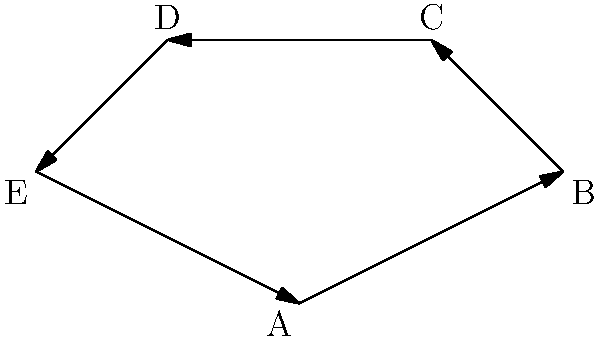In the directed cyclic graph above, each node represents a different point in time, and each edge represents a time travel event. If a time traveler starts at point A and follows the path of the graph, which temporal paradox is most likely to occur, and why is this paradox particularly relevant to classic 1960s sci-fi storytelling? To answer this question, let's break down the analysis step-by-step:

1. Graph structure: The graph is a directed cycle with 5 nodes (A, B, C, D, E) connected in a loop.

2. Time travel interpretation:
   - Each node represents a distinct point in time.
   - Each edge represents a time travel event from one point to another.
   - The cycle suggests that a traveler can eventually return to their starting point in time.

3. Paradox identification: The most likely paradox to occur in this scenario is the "Causal Loop" or "Bootstrap Paradox."

4. Explanation of the Causal Loop:
   - The time traveler starts at A and moves through time to B, C, D, E, and back to A.
   - This creates a closed timelike curve where events influence themselves.
   - Information or objects can exist without a clear point of origin.

5. Relevance to 1960s sci-fi:
   - Classic shows like "The Twilight Zone" and "Star Trek" often explored time travel.
   - These shows frequently used paradoxes to create mind-bending storylines.
   - The Causal Loop allows for complex, interconnected plots that challenge causality.

6. Storytelling potential:
   - It raises questions about free will and determinism.
   - It allows for creative plot devices where future events cause past events.
   - It can be used to create dramatic tension and philosophical discussions.

7. Example in 1960s context:
   - A character might receive plans for a time machine from their future self, build it, and then travel back to give the plans to their past self, creating a loop with no clear origin.

The Causal Loop paradox, as represented by this cyclic graph, perfectly encapsulates the blend of scientific speculation and philosophical questioning that was characteristic of classic 1960s science fiction storytelling.
Answer: Causal Loop (Bootstrap) Paradox 